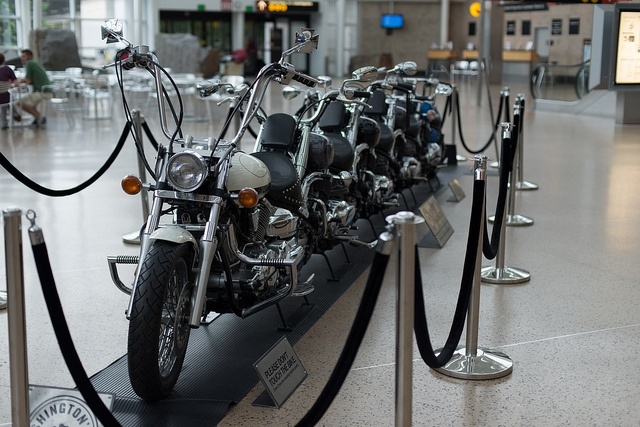Describe the objects in this image and their specific colors. I can see motorcycle in teal, black, gray, darkgray, and lightgray tones, motorcycle in teal, black, gray, darkgray, and purple tones, motorcycle in teal, black, purple, darkgray, and darkblue tones, motorcycle in teal, black, gray, and darkgray tones, and chair in teal, darkgray, lightgray, and gray tones in this image. 